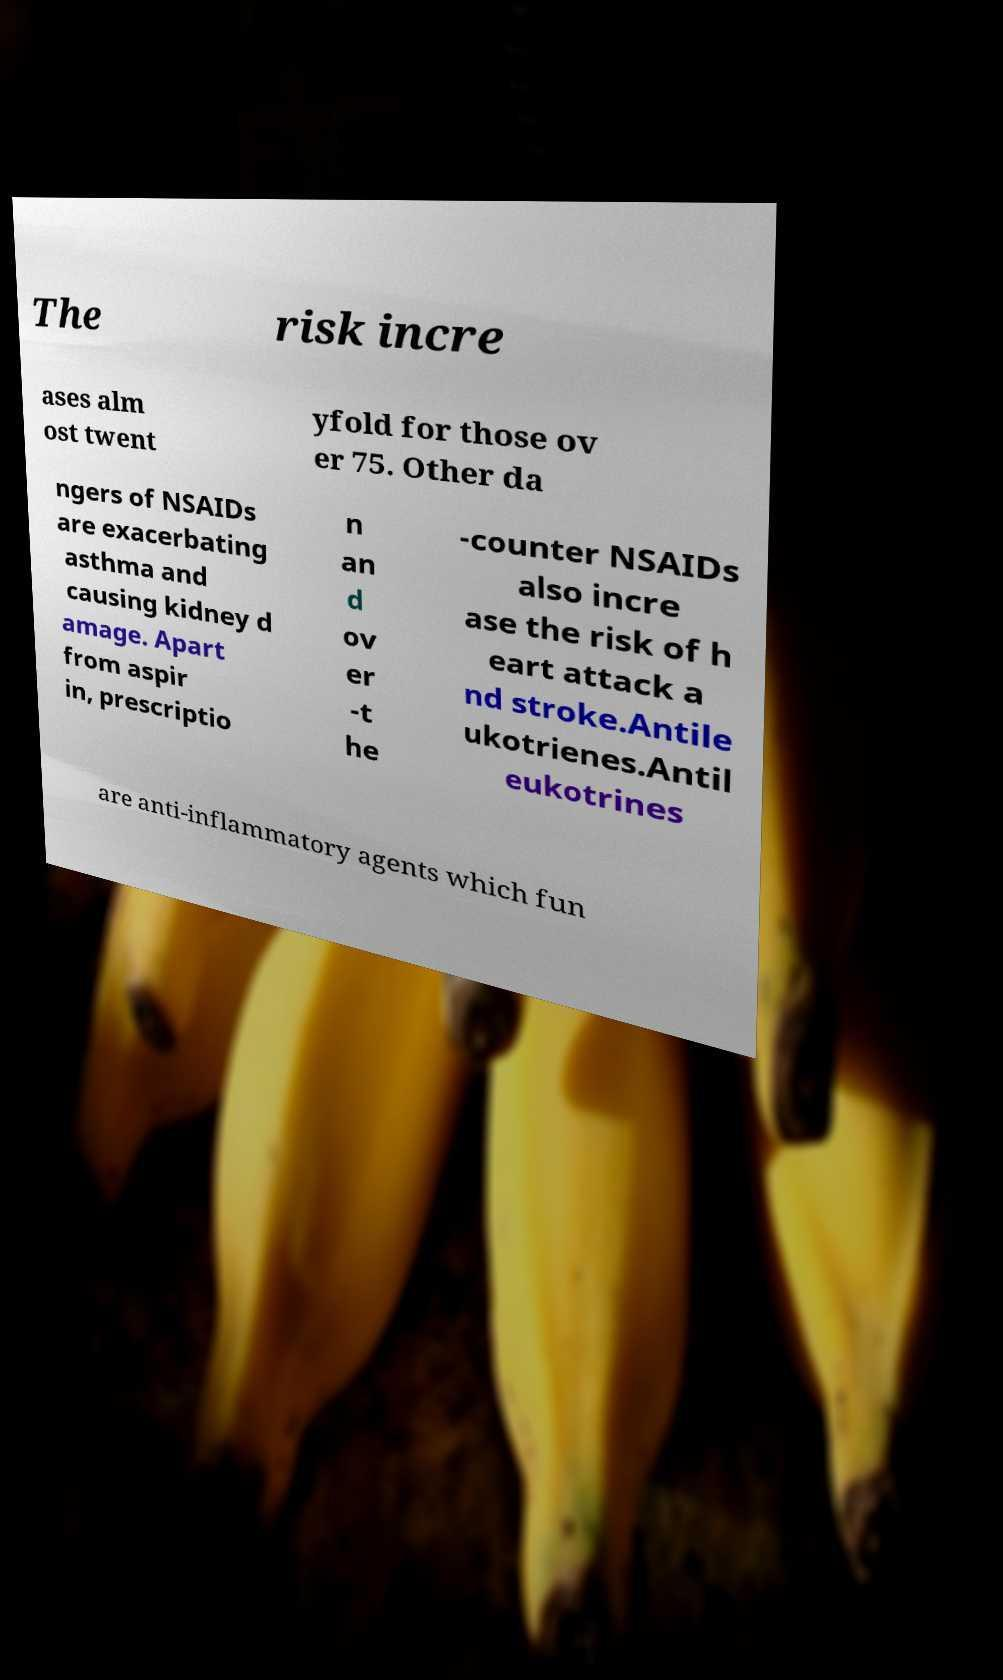What are the risks associated with NSAIDs as mentioned in this image? The image highlights that NSAIDs significantly increase the risk of health complications in older adults, particularly those over 75. They can exacerbate asthma, cause kidney damage, and increase the likelihood of heart attacks and strokes. These risks are particularly critical as they affect those who are potentially already vulnerable. 